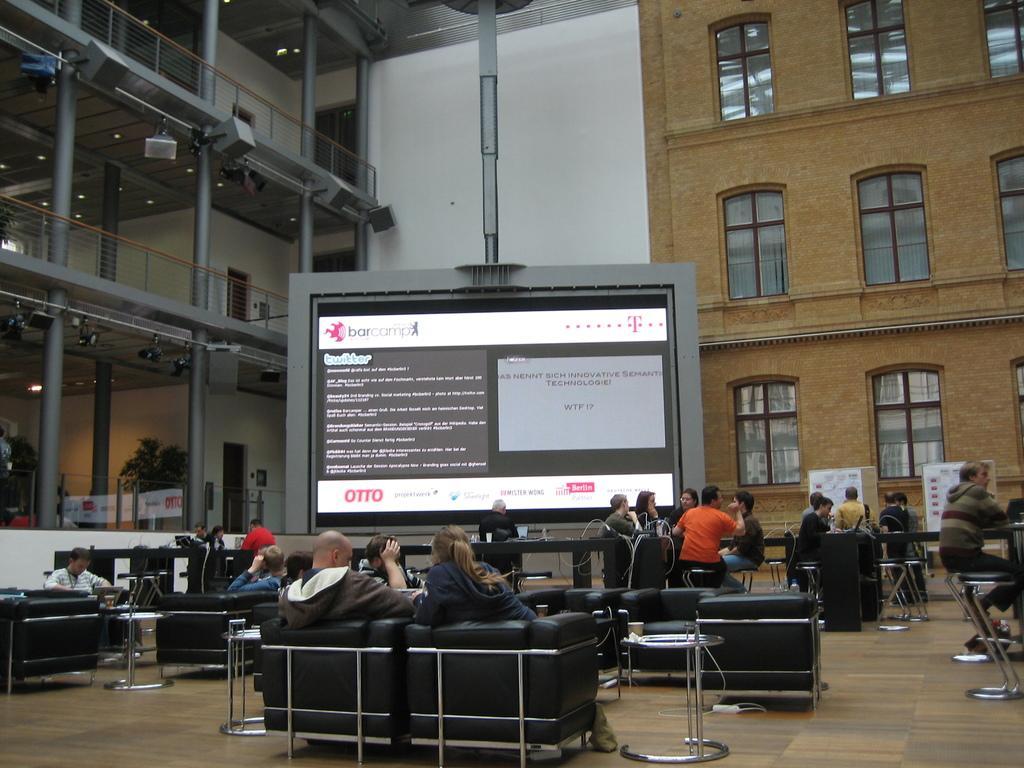In one or two sentences, can you explain what this image depicts? The image is taken inside a room. There are many people in the image. There are many couches, tables and chairs. People are sitting on couches and chairs. There is a big screen in the image on which some text is displayed. There are many glass windows on the wall. On the left corner there is railing, pillars, lights. There is also a door and a plant beside it. 